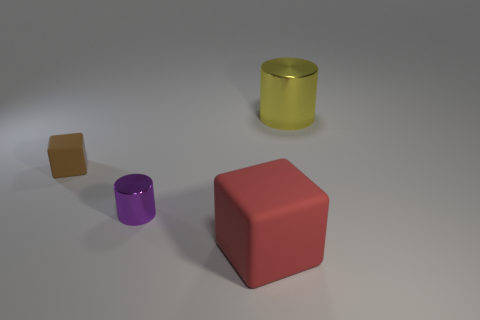Add 3 cylinders. How many objects exist? 7 Add 4 big blue things. How many big blue things exist? 4 Subtract 0 purple balls. How many objects are left? 4 Subtract all small green matte balls. Subtract all large yellow cylinders. How many objects are left? 3 Add 1 large shiny objects. How many large shiny objects are left? 2 